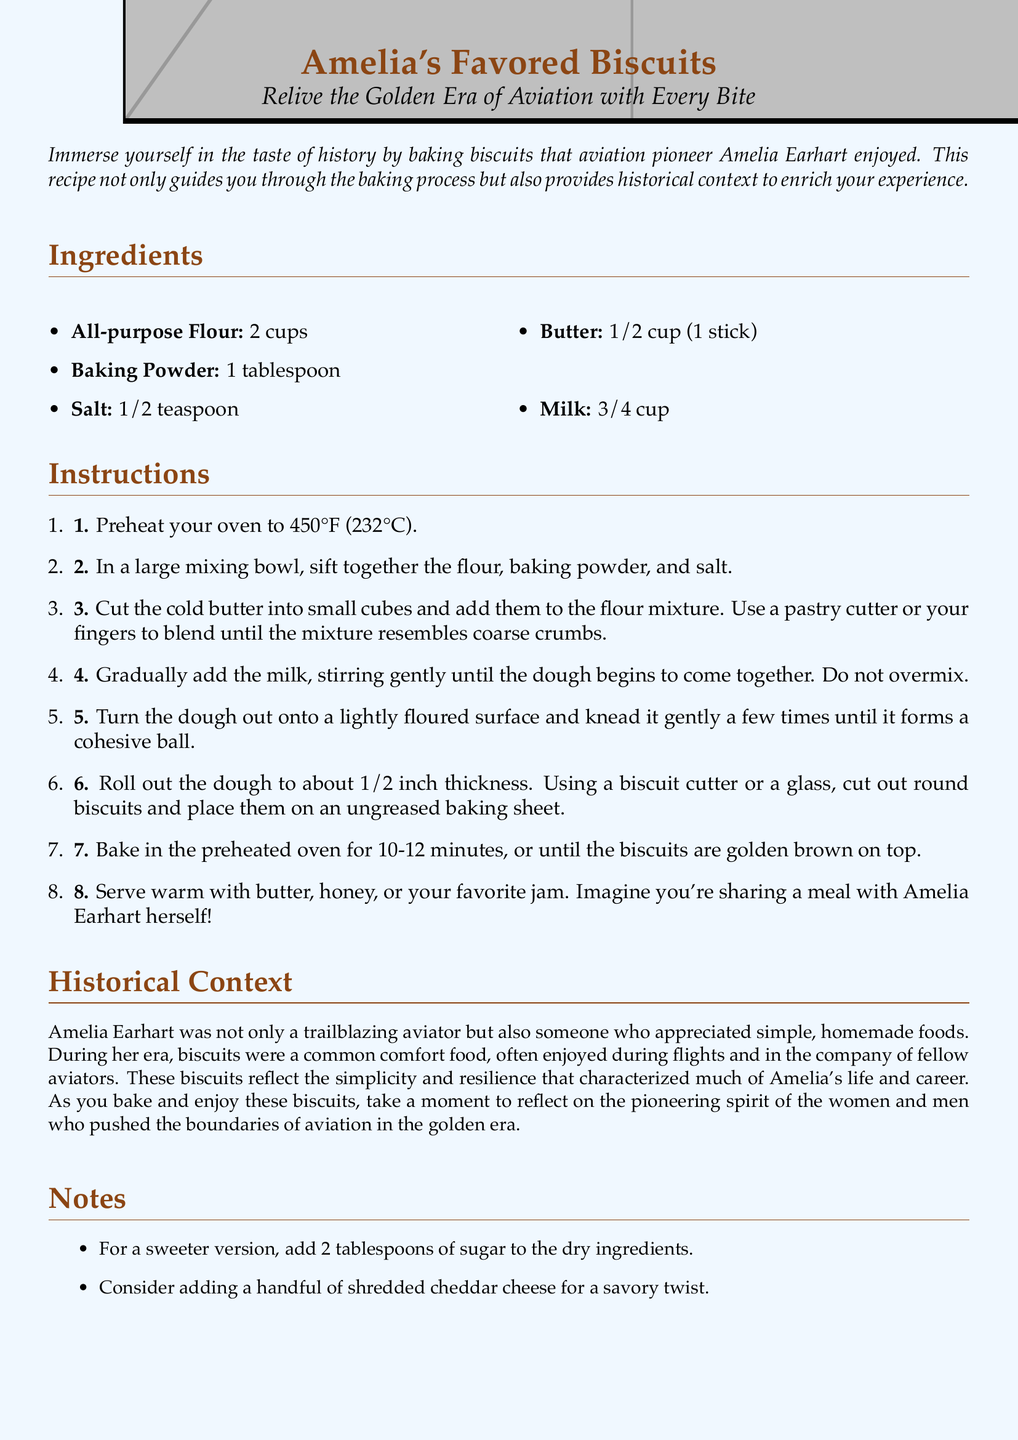What are the main ingredients for the biscuits? The main ingredients can be found in the "Ingredients" section, which lists all that is needed to make the biscuits.
Answer: All-purpose Flour, Baking Powder, Salt, Butter, Milk How much baking powder is needed? The amount of baking powder is specified in the "Ingredients" section of the document.
Answer: 1 tablespoon What temperature should the oven be preheated to? The preheating temperature is detailed in the first instruction of the recipe.
Answer: 450°F How long do the biscuits need to bake? The baking time is mentioned in instruction 7 of the recipe, mentioning the duration for which biscuits should be baked.
Answer: 10-12 minutes What is a suggested way to enjoy the biscuits? The document suggests enjoying the biscuits in a specific way in the last instruction.
Answer: With butter, honey, or your favorite jam What historical figure is this recipe associated with? The historical figure is prominently mentioned in the title and throughout the text.
Answer: Amelia Earhart What type of document is this? The structure and content are characteristic of this type, which is meant for cooking guidance.
Answer: Recipe card What can be added for a sweeter version? This is specified as an additional note in the "Notes" section of the document.
Answer: 2 tablespoons of sugar What is the purpose of the "Historical Context" section? The section explains the significance and background related to the recipe and the aviator.
Answer: To enrich the baking experience with historical context 